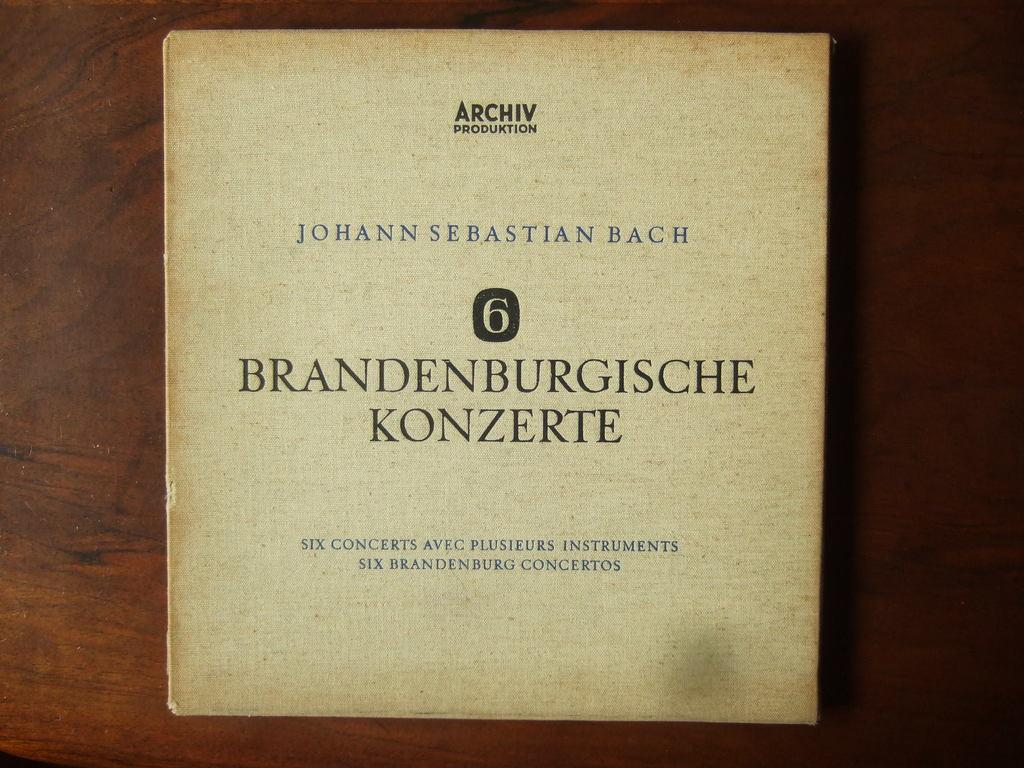<image>
Share a concise interpretation of the image provided. A tan CD cover with a collection by Johann Sebastian Bach. 